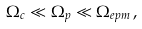Convert formula to latex. <formula><loc_0><loc_0><loc_500><loc_500>\Omega _ { c } \ll \Omega _ { p } \ll \Omega _ { e p m } \, ,</formula> 